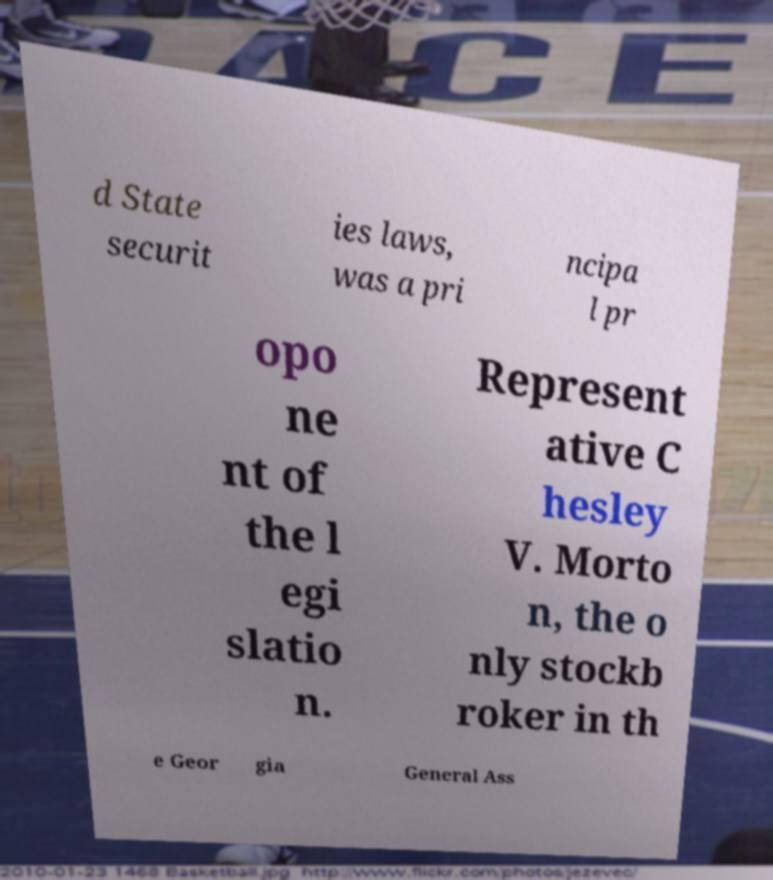There's text embedded in this image that I need extracted. Can you transcribe it verbatim? d State securit ies laws, was a pri ncipa l pr opo ne nt of the l egi slatio n. Represent ative C hesley V. Morto n, the o nly stockb roker in th e Geor gia General Ass 